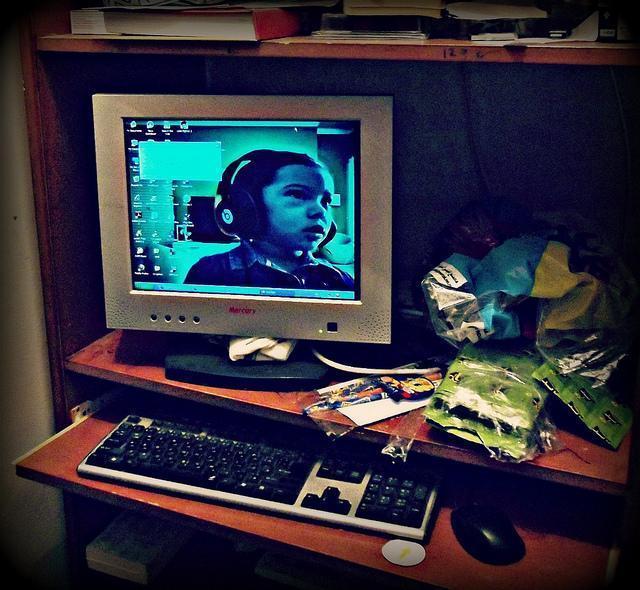How many computer screens are there?
Give a very brief answer. 1. 